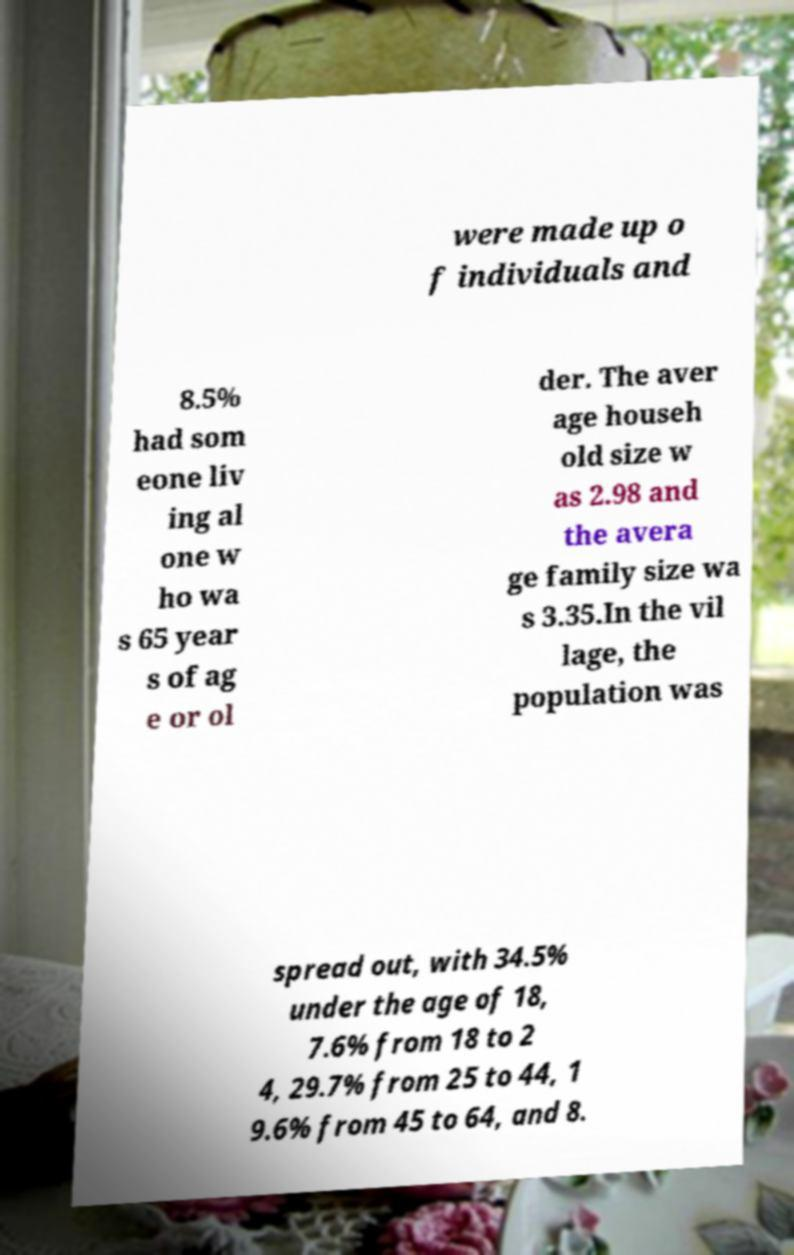Please read and relay the text visible in this image. What does it say? were made up o f individuals and 8.5% had som eone liv ing al one w ho wa s 65 year s of ag e or ol der. The aver age househ old size w as 2.98 and the avera ge family size wa s 3.35.In the vil lage, the population was spread out, with 34.5% under the age of 18, 7.6% from 18 to 2 4, 29.7% from 25 to 44, 1 9.6% from 45 to 64, and 8. 